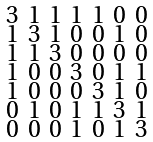Convert formula to latex. <formula><loc_0><loc_0><loc_500><loc_500>\begin{smallmatrix} 3 & 1 & 1 & 1 & 1 & 0 & 0 \\ 1 & 3 & 1 & 0 & 0 & 1 & 0 \\ 1 & 1 & 3 & 0 & 0 & 0 & 0 \\ 1 & 0 & 0 & 3 & 0 & 1 & 1 \\ 1 & 0 & 0 & 0 & 3 & 1 & 0 \\ 0 & 1 & 0 & 1 & 1 & 3 & 1 \\ 0 & 0 & 0 & 1 & 0 & 1 & 3 \end{smallmatrix}</formula> 